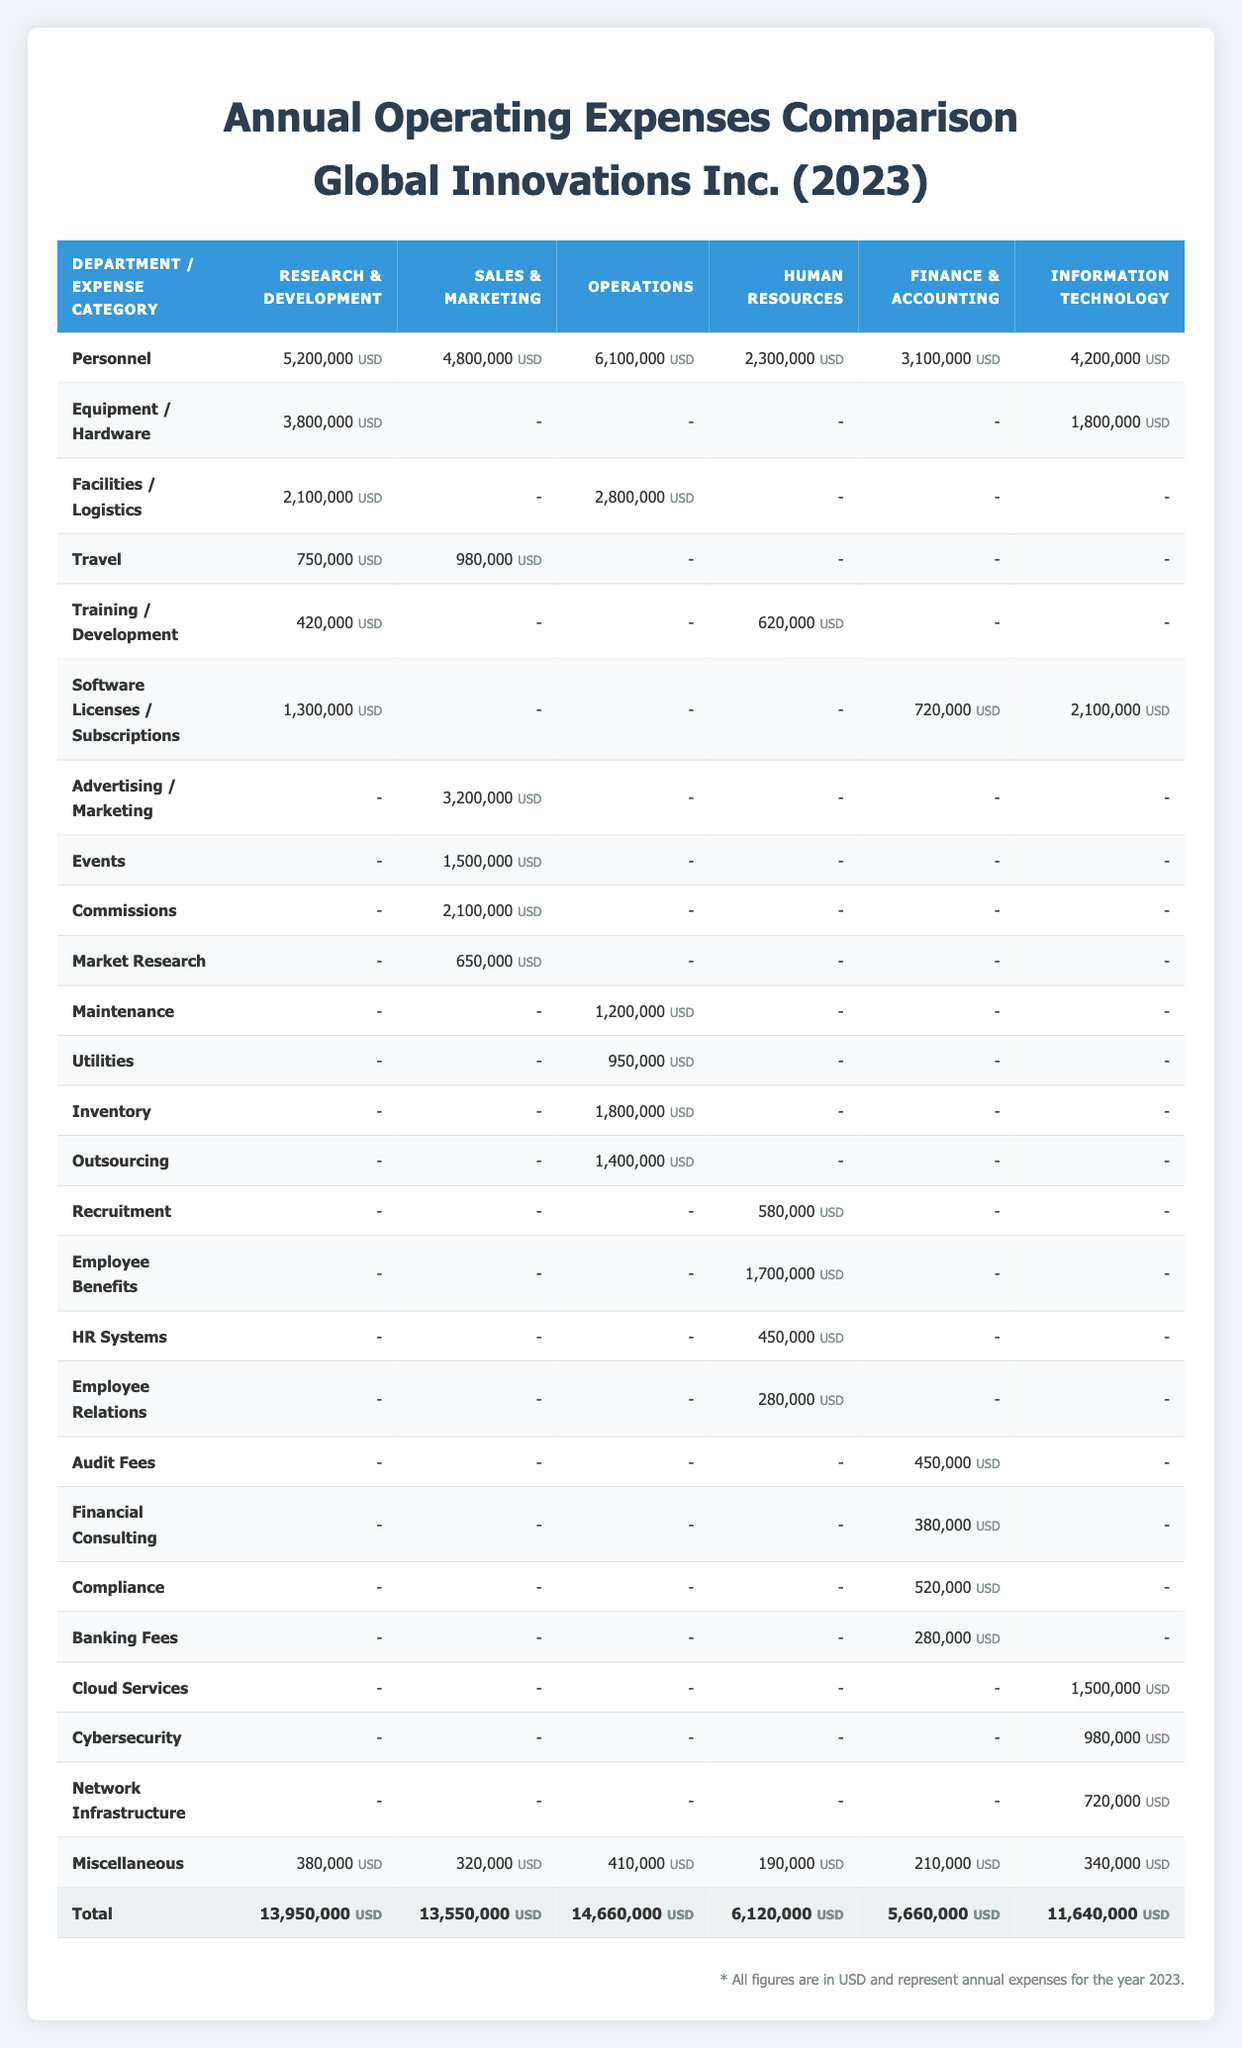What are the total annual operating expenses for the Operations department? The total for the Operations department can be found in the total row of the table under the Operations column, which indicates a value of 14,660,000 USD.
Answer: 14,660,000 USD Which department has the highest personnel costs? Looking at the Personnel row, the Operations department has personnel costs of 6,100,000 USD, which is greater than any other department.
Answer: Operations How much did Sales & Marketing spend on advertising? In the row for Advertising / Marketing, the Sales & Marketing department spent 3,200,000 USD.
Answer: 3,200,000 USD What is the difference in total expenses between Research & Development and Human Resources? The total for Research & Development is 13,950,000 USD, and for Human Resources, it is 6,120,000 USD. The difference is calculated as 13,950,000 - 6,120,000 = 7,830,000 USD.
Answer: 7,830,000 USD Did the Information Technology department incur expenses for travel? When checking the Travel row under Information Technology, there are no expenses listed. It confirms that Information Technology did not incur travel expenses.
Answer: No What is the combined total expenditure for the Operations and Human Resources departments? The total for Operations is 14,660,000 USD and for Human Resources, it is 6,120,000 USD. Adding the two values gives us 14,660,000 + 6,120,000 = 20,780,000 USD.
Answer: 20,780,000 USD Which category had the highest spending in the Finance & Accounting department? In the Finance & Accounting department, looking at the various categories, the personnel costs of 3,100,000 USD were the highest compared to other expense categories listed for this department.
Answer: Personnel Is the total expenditure for the Information Technology department higher than the total for Finance & Accounting? The total for Information Technology is 11,640,000 USD, and for Finance & Accounting, it is 5,660,000 USD. Comparing these two amounts, Information Technology is indeed higher.
Answer: Yes What is the total amount spent on travel across all departments? To find this total, we look at the travel costs for each department: Research & Development (750,000 USD) + Sales & Marketing (980,000 USD) + Operations (0 USD) + Human Resources (0 USD) + Finance & Accounting (0 USD) + Information Technology (0 USD). Summing these values gives 750,000 + 980,000 = 1,730,000 USD.
Answer: 1,730,000 USD 